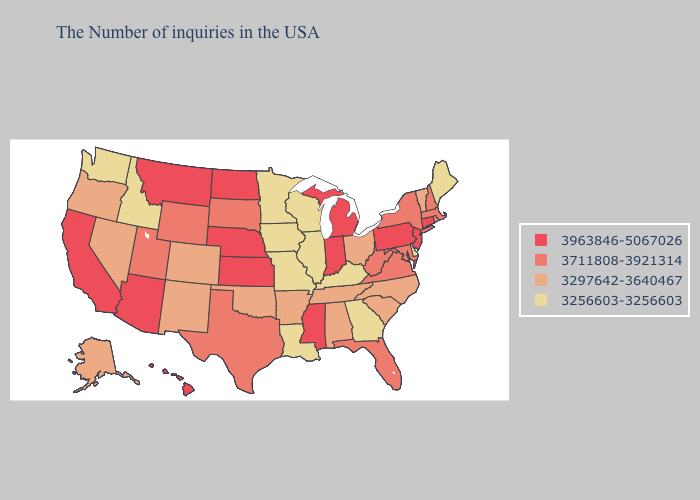Among the states that border Alabama , does Florida have the highest value?
Concise answer only. No. What is the value of Nebraska?
Short answer required. 3963846-5067026. Does Minnesota have a lower value than Iowa?
Answer briefly. No. What is the lowest value in the USA?
Short answer required. 3256603-3256603. What is the highest value in states that border Wisconsin?
Give a very brief answer. 3963846-5067026. Name the states that have a value in the range 3711808-3921314?
Concise answer only. Massachusetts, Rhode Island, New Hampshire, New York, Maryland, Virginia, West Virginia, Florida, Texas, South Dakota, Wyoming, Utah. Name the states that have a value in the range 3256603-3256603?
Answer briefly. Maine, Delaware, Georgia, Kentucky, Wisconsin, Illinois, Louisiana, Missouri, Minnesota, Iowa, Idaho, Washington. What is the value of Washington?
Be succinct. 3256603-3256603. What is the highest value in states that border Washington?
Short answer required. 3297642-3640467. Which states have the highest value in the USA?
Quick response, please. Connecticut, New Jersey, Pennsylvania, Michigan, Indiana, Mississippi, Kansas, Nebraska, North Dakota, Montana, Arizona, California, Hawaii. What is the value of Delaware?
Short answer required. 3256603-3256603. Does Delaware have the lowest value in the South?
Keep it brief. Yes. What is the lowest value in the USA?
Be succinct. 3256603-3256603. What is the lowest value in the Northeast?
Give a very brief answer. 3256603-3256603. Does the first symbol in the legend represent the smallest category?
Answer briefly. No. 